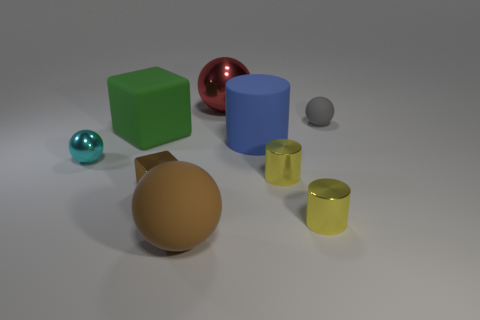The large shiny thing has what color?
Make the answer very short. Red. The large thing that is behind the tiny gray matte ball right of the big green matte thing is what shape?
Keep it short and to the point. Sphere. Are there any other blue cylinders made of the same material as the blue cylinder?
Your response must be concise. No. There is a matte ball to the left of the gray thing; is its size the same as the red metallic ball?
Give a very brief answer. Yes. What number of cyan things are either large things or large cylinders?
Provide a succinct answer. 0. There is a yellow cylinder behind the tiny block; what material is it?
Offer a terse response. Metal. How many metallic spheres are in front of the metallic object behind the blue object?
Offer a terse response. 1. What number of cyan shiny objects are the same shape as the big blue object?
Your response must be concise. 0. How many tiny brown metallic cubes are there?
Your answer should be compact. 1. What is the color of the tiny ball that is on the left side of the tiny cube?
Your answer should be very brief. Cyan. 